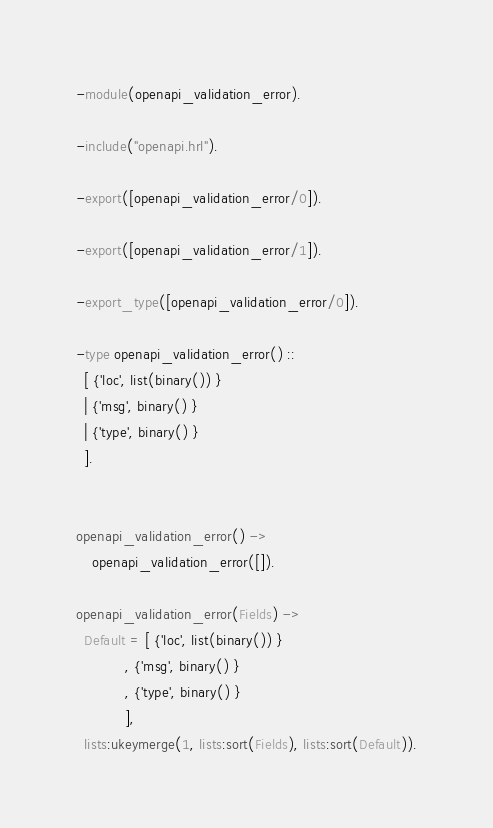Convert code to text. <code><loc_0><loc_0><loc_500><loc_500><_Erlang_>-module(openapi_validation_error).

-include("openapi.hrl").

-export([openapi_validation_error/0]).

-export([openapi_validation_error/1]).

-export_type([openapi_validation_error/0]).

-type openapi_validation_error() ::
  [ {'loc', list(binary()) }
  | {'msg', binary() }
  | {'type', binary() }
  ].


openapi_validation_error() ->
    openapi_validation_error([]).

openapi_validation_error(Fields) ->
  Default = [ {'loc', list(binary()) }
            , {'msg', binary() }
            , {'type', binary() }
            ],
  lists:ukeymerge(1, lists:sort(Fields), lists:sort(Default)).

</code> 